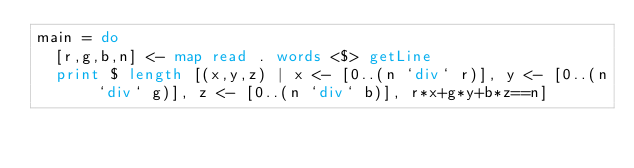Convert code to text. <code><loc_0><loc_0><loc_500><loc_500><_Haskell_>main = do
  [r,g,b,n] <- map read . words <$> getLine
  print $ length [(x,y,z) | x <- [0..(n `div` r)], y <- [0..(n `div` g)], z <- [0..(n `div` b)], r*x+g*y+b*z==n]
</code> 